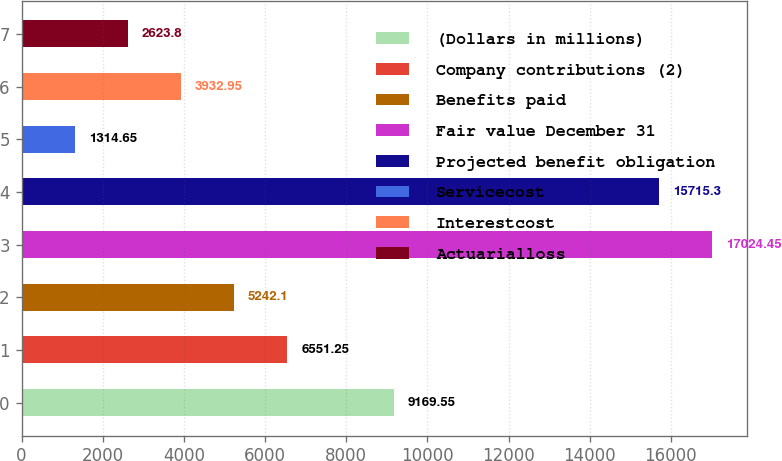<chart> <loc_0><loc_0><loc_500><loc_500><bar_chart><fcel>(Dollars in millions)<fcel>Company contributions (2)<fcel>Benefits paid<fcel>Fair value December 31<fcel>Projected benefit obligation<fcel>Servicecost<fcel>Interestcost<fcel>Actuarialloss<nl><fcel>9169.55<fcel>6551.25<fcel>5242.1<fcel>17024.5<fcel>15715.3<fcel>1314.65<fcel>3932.95<fcel>2623.8<nl></chart> 